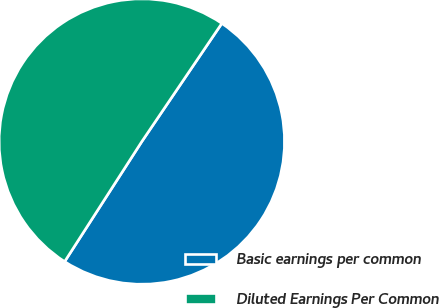<chart> <loc_0><loc_0><loc_500><loc_500><pie_chart><fcel>Basic earnings per common<fcel>Diluted Earnings Per Common<nl><fcel>49.62%<fcel>50.38%<nl></chart> 